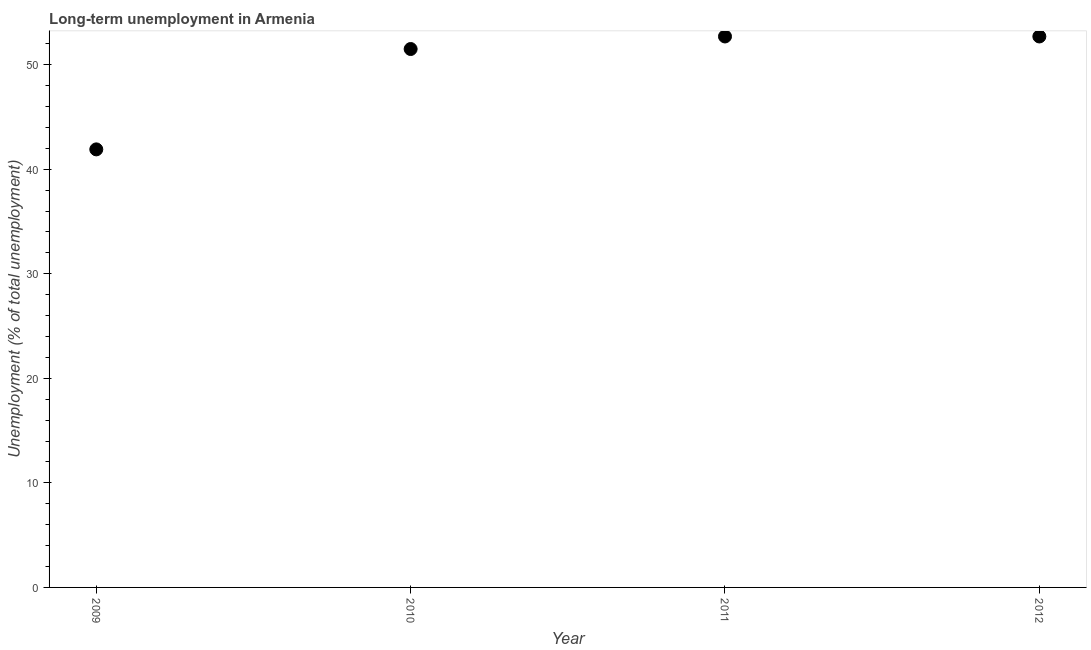What is the long-term unemployment in 2010?
Give a very brief answer. 51.5. Across all years, what is the maximum long-term unemployment?
Provide a short and direct response. 52.7. Across all years, what is the minimum long-term unemployment?
Make the answer very short. 41.9. In which year was the long-term unemployment minimum?
Keep it short and to the point. 2009. What is the sum of the long-term unemployment?
Make the answer very short. 198.8. What is the difference between the long-term unemployment in 2011 and 2012?
Ensure brevity in your answer.  0. What is the average long-term unemployment per year?
Your answer should be very brief. 49.7. What is the median long-term unemployment?
Your answer should be very brief. 52.1. Do a majority of the years between 2010 and 2012 (inclusive) have long-term unemployment greater than 34 %?
Your response must be concise. Yes. What is the ratio of the long-term unemployment in 2010 to that in 2011?
Your answer should be compact. 0.98. Is the difference between the long-term unemployment in 2009 and 2011 greater than the difference between any two years?
Keep it short and to the point. Yes. What is the difference between the highest and the lowest long-term unemployment?
Provide a succinct answer. 10.8. In how many years, is the long-term unemployment greater than the average long-term unemployment taken over all years?
Your response must be concise. 3. Does the long-term unemployment monotonically increase over the years?
Give a very brief answer. No. How many dotlines are there?
Your answer should be compact. 1. How many years are there in the graph?
Your answer should be compact. 4. Are the values on the major ticks of Y-axis written in scientific E-notation?
Make the answer very short. No. Does the graph contain any zero values?
Ensure brevity in your answer.  No. What is the title of the graph?
Give a very brief answer. Long-term unemployment in Armenia. What is the label or title of the Y-axis?
Ensure brevity in your answer.  Unemployment (% of total unemployment). What is the Unemployment (% of total unemployment) in 2009?
Provide a succinct answer. 41.9. What is the Unemployment (% of total unemployment) in 2010?
Provide a short and direct response. 51.5. What is the Unemployment (% of total unemployment) in 2011?
Your response must be concise. 52.7. What is the Unemployment (% of total unemployment) in 2012?
Ensure brevity in your answer.  52.7. What is the ratio of the Unemployment (% of total unemployment) in 2009 to that in 2010?
Your answer should be very brief. 0.81. What is the ratio of the Unemployment (% of total unemployment) in 2009 to that in 2011?
Your answer should be compact. 0.8. What is the ratio of the Unemployment (% of total unemployment) in 2009 to that in 2012?
Keep it short and to the point. 0.8. What is the ratio of the Unemployment (% of total unemployment) in 2010 to that in 2011?
Offer a terse response. 0.98. What is the ratio of the Unemployment (% of total unemployment) in 2011 to that in 2012?
Ensure brevity in your answer.  1. 